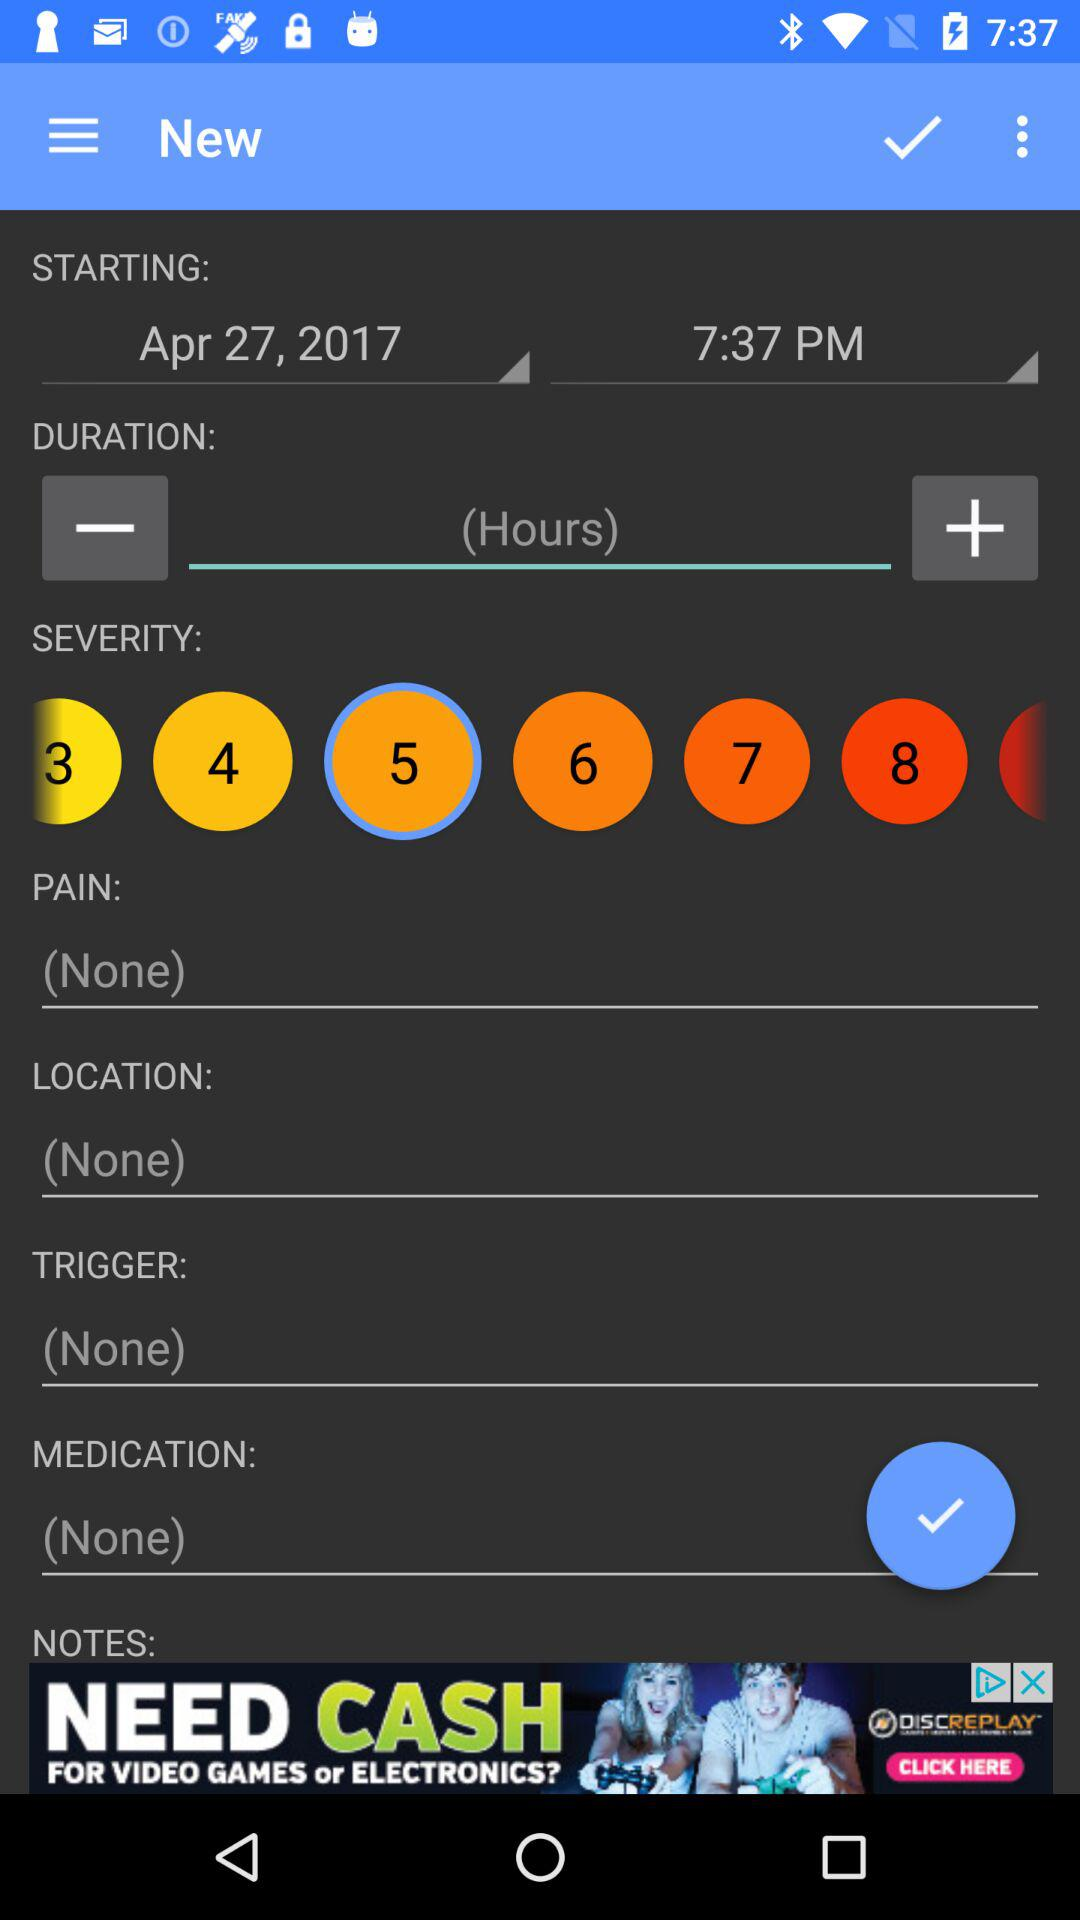Which option is selected in "SEVERITY"? The selected option in "SEVERITY" is 5. 